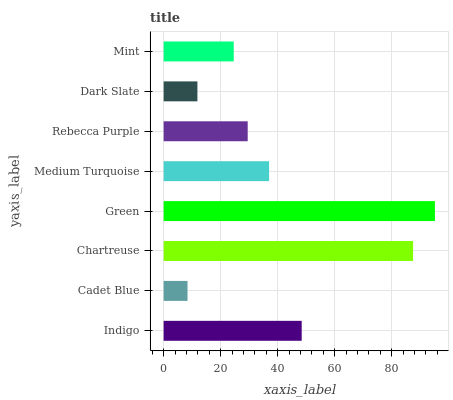Is Cadet Blue the minimum?
Answer yes or no. Yes. Is Green the maximum?
Answer yes or no. Yes. Is Chartreuse the minimum?
Answer yes or no. No. Is Chartreuse the maximum?
Answer yes or no. No. Is Chartreuse greater than Cadet Blue?
Answer yes or no. Yes. Is Cadet Blue less than Chartreuse?
Answer yes or no. Yes. Is Cadet Blue greater than Chartreuse?
Answer yes or no. No. Is Chartreuse less than Cadet Blue?
Answer yes or no. No. Is Medium Turquoise the high median?
Answer yes or no. Yes. Is Rebecca Purple the low median?
Answer yes or no. Yes. Is Dark Slate the high median?
Answer yes or no. No. Is Chartreuse the low median?
Answer yes or no. No. 